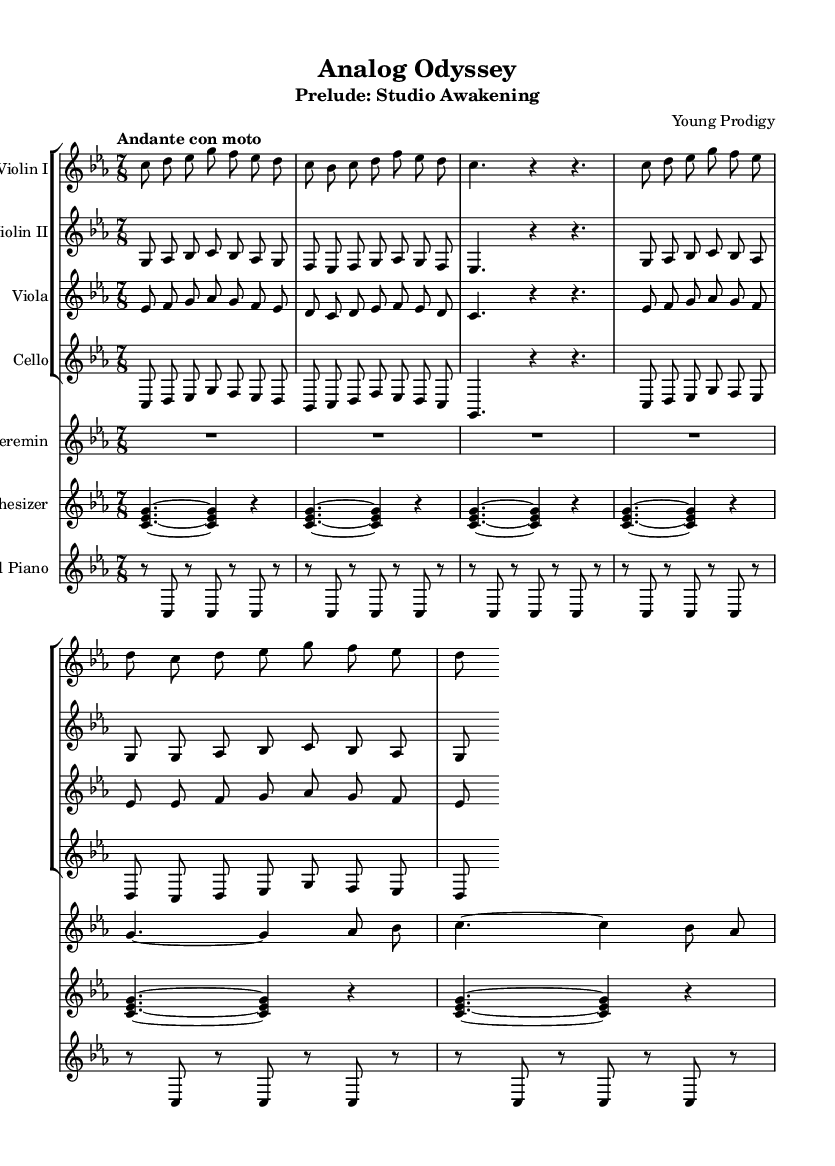What is the key signature of this music? The key signature is C minor, which is indicated by the three flat symbols placed at the beginning of the staff.
Answer: C minor What is the time signature of this music? The time signature is 7/8, which is shown at the beginning of the score. This indicates that there are seven eighth notes in each measure.
Answer: 7/8 What is the tempo marking for this piece? The tempo marking "Andante con moto" indicates a moderately slow tempo with some movement, which can be found towards the beginning of the sheet music.
Answer: Andante con moto How many measures are repeated in the strings sections? Each strings section features a repeat of two measures, indicated by the text "repeat unfold 2," which specifies that the preceding measures should be played twice.
Answer: 2 Which unconventional instruments are featured in this composition? The composition includes a theremin and a synthesizer, which are identified by their instrument labels on the staff within the score.
Answer: Theremin, synthesizer What type of additional sound is incorporated in the prepared piano part? The prepared piano part utilizes unconventional sounds generated by placing objects on the piano strings, which can be inferred from the rests and notes in the part that indicate unusual playing techniques.
Answer: Unconventional sounds What rhythmic pattern is predominantly featured in the synthesizer part? The synthesizer is characterized by a repeated rhythmic pattern of sustained chords played as whole notes, indicated by the notation that designates the duration as four beats each.
Answer: Sustained chords 